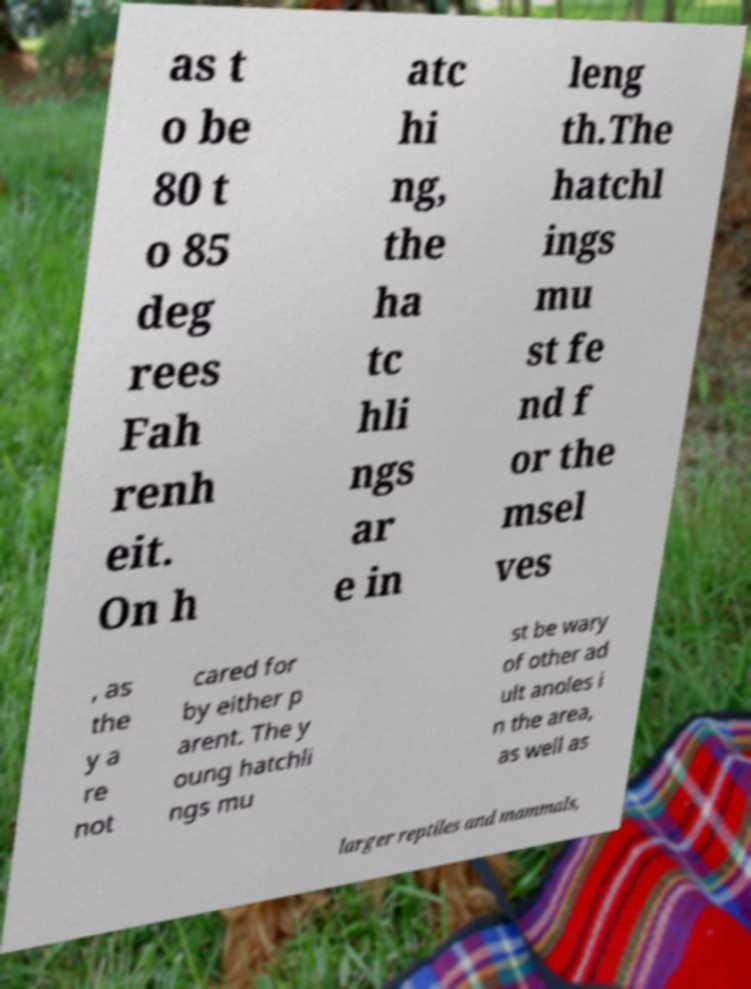Please read and relay the text visible in this image. What does it say? as t o be 80 t o 85 deg rees Fah renh eit. On h atc hi ng, the ha tc hli ngs ar e in leng th.The hatchl ings mu st fe nd f or the msel ves , as the y a re not cared for by either p arent. The y oung hatchli ngs mu st be wary of other ad ult anoles i n the area, as well as larger reptiles and mammals, 